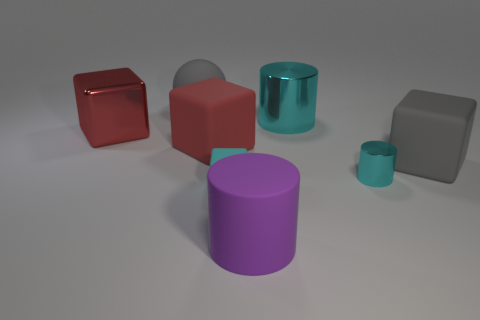What number of other cubes are the same color as the large metallic block?
Provide a succinct answer. 1. Is there a large cylinder that has the same material as the gray cube?
Give a very brief answer. Yes. What material is the cyan cylinder that is the same size as the gray matte block?
Offer a very short reply. Metal. The large cylinder behind the red object left of the large gray thing to the left of the big gray block is what color?
Give a very brief answer. Cyan. There is a large metal object that is on the left side of the big purple matte cylinder; is its shape the same as the big gray rubber thing that is in front of the gray matte ball?
Your answer should be compact. Yes. What number of large purple matte objects are there?
Offer a very short reply. 1. What color is the metal cylinder that is the same size as the matte ball?
Your answer should be very brief. Cyan. Are the big gray object right of the tiny cyan matte cube and the small object that is right of the tiny cyan matte cube made of the same material?
Your response must be concise. No. What size is the cyan object that is in front of the metal cylinder to the right of the big cyan metal cylinder?
Make the answer very short. Small. What is the thing behind the big cyan cylinder made of?
Make the answer very short. Rubber. 